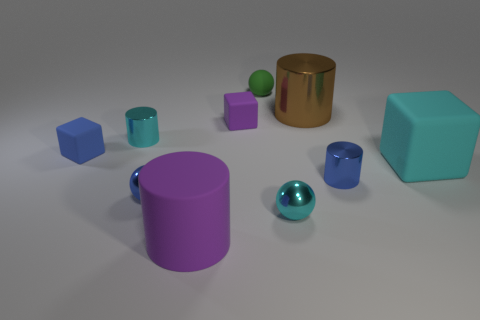There is a tiny cyan thing that is behind the large cyan block; what is it made of?
Give a very brief answer. Metal. There is a tiny cylinder that is the same color as the large block; what material is it?
Provide a short and direct response. Metal. What number of matte objects are tiny cyan balls or large balls?
Give a very brief answer. 0. What number of other things are the same shape as the big shiny thing?
Your response must be concise. 3. Are there more rubber spheres than red cylinders?
Ensure brevity in your answer.  Yes. There is a matte thing that is in front of the big rubber thing behind the cyan metal thing in front of the tiny blue shiny cylinder; what is its size?
Your response must be concise. Large. There is a cyan thing that is to the right of the big metal thing; how big is it?
Ensure brevity in your answer.  Large. How many objects are big blue rubber blocks or small cylinders that are in front of the cyan rubber block?
Give a very brief answer. 1. How many other things are the same size as the cyan metallic cylinder?
Make the answer very short. 6. There is a purple object that is the same shape as the big brown metallic thing; what material is it?
Offer a very short reply. Rubber. 